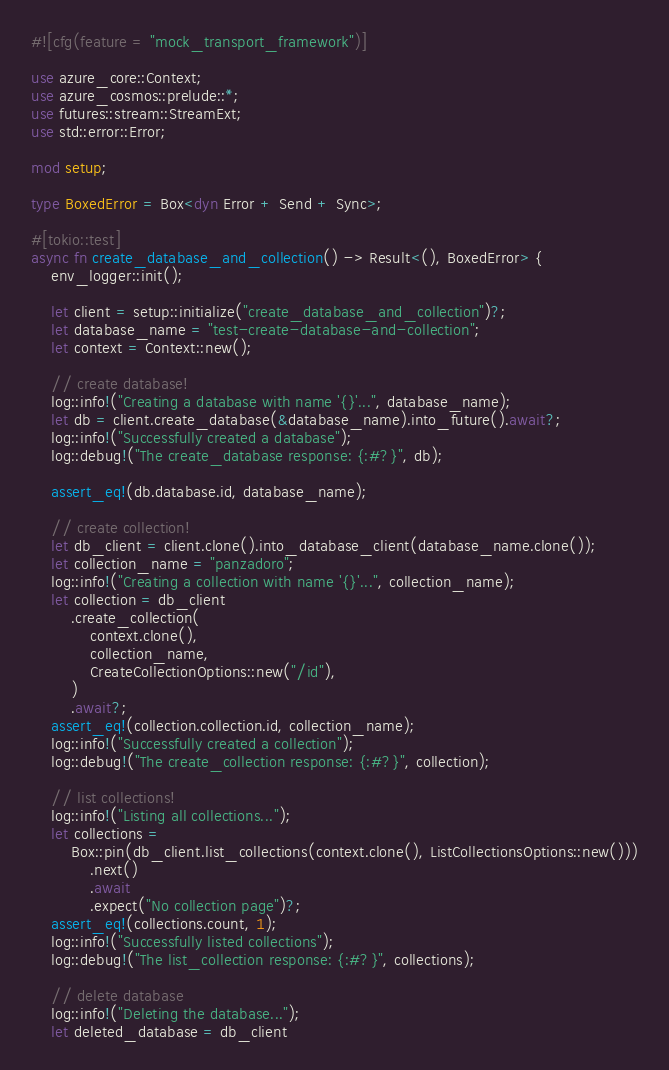<code> <loc_0><loc_0><loc_500><loc_500><_Rust_>#![cfg(feature = "mock_transport_framework")]

use azure_core::Context;
use azure_cosmos::prelude::*;
use futures::stream::StreamExt;
use std::error::Error;

mod setup;

type BoxedError = Box<dyn Error + Send + Sync>;

#[tokio::test]
async fn create_database_and_collection() -> Result<(), BoxedError> {
    env_logger::init();

    let client = setup::initialize("create_database_and_collection")?;
    let database_name = "test-create-database-and-collection";
    let context = Context::new();

    // create database!
    log::info!("Creating a database with name '{}'...", database_name);
    let db = client.create_database(&database_name).into_future().await?;
    log::info!("Successfully created a database");
    log::debug!("The create_database response: {:#?}", db);

    assert_eq!(db.database.id, database_name);

    // create collection!
    let db_client = client.clone().into_database_client(database_name.clone());
    let collection_name = "panzadoro";
    log::info!("Creating a collection with name '{}'...", collection_name);
    let collection = db_client
        .create_collection(
            context.clone(),
            collection_name,
            CreateCollectionOptions::new("/id"),
        )
        .await?;
    assert_eq!(collection.collection.id, collection_name);
    log::info!("Successfully created a collection");
    log::debug!("The create_collection response: {:#?}", collection);

    // list collections!
    log::info!("Listing all collections...");
    let collections =
        Box::pin(db_client.list_collections(context.clone(), ListCollectionsOptions::new()))
            .next()
            .await
            .expect("No collection page")?;
    assert_eq!(collections.count, 1);
    log::info!("Successfully listed collections");
    log::debug!("The list_collection response: {:#?}", collections);

    // delete database
    log::info!("Deleting the database...");
    let deleted_database = db_client</code> 